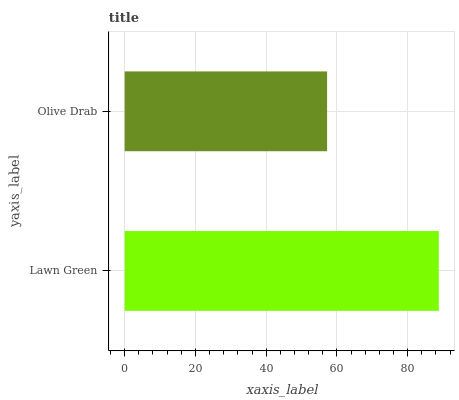Is Olive Drab the minimum?
Answer yes or no. Yes. Is Lawn Green the maximum?
Answer yes or no. Yes. Is Olive Drab the maximum?
Answer yes or no. No. Is Lawn Green greater than Olive Drab?
Answer yes or no. Yes. Is Olive Drab less than Lawn Green?
Answer yes or no. Yes. Is Olive Drab greater than Lawn Green?
Answer yes or no. No. Is Lawn Green less than Olive Drab?
Answer yes or no. No. Is Lawn Green the high median?
Answer yes or no. Yes. Is Olive Drab the low median?
Answer yes or no. Yes. Is Olive Drab the high median?
Answer yes or no. No. Is Lawn Green the low median?
Answer yes or no. No. 